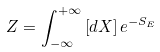<formula> <loc_0><loc_0><loc_500><loc_500>Z = \int _ { - \infty } ^ { + \infty } \left [ d X \right ] e ^ { - S _ { E } }</formula> 